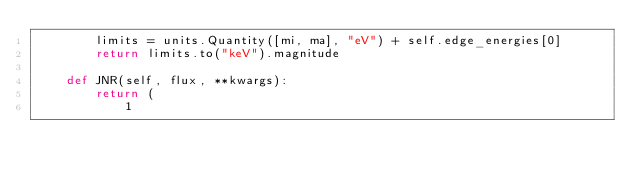Convert code to text. <code><loc_0><loc_0><loc_500><loc_500><_Python_>        limits = units.Quantity([mi, ma], "eV") + self.edge_energies[0]
        return limits.to("keV").magnitude

    def JNR(self, flux, **kwargs):
        return (
            1</code> 